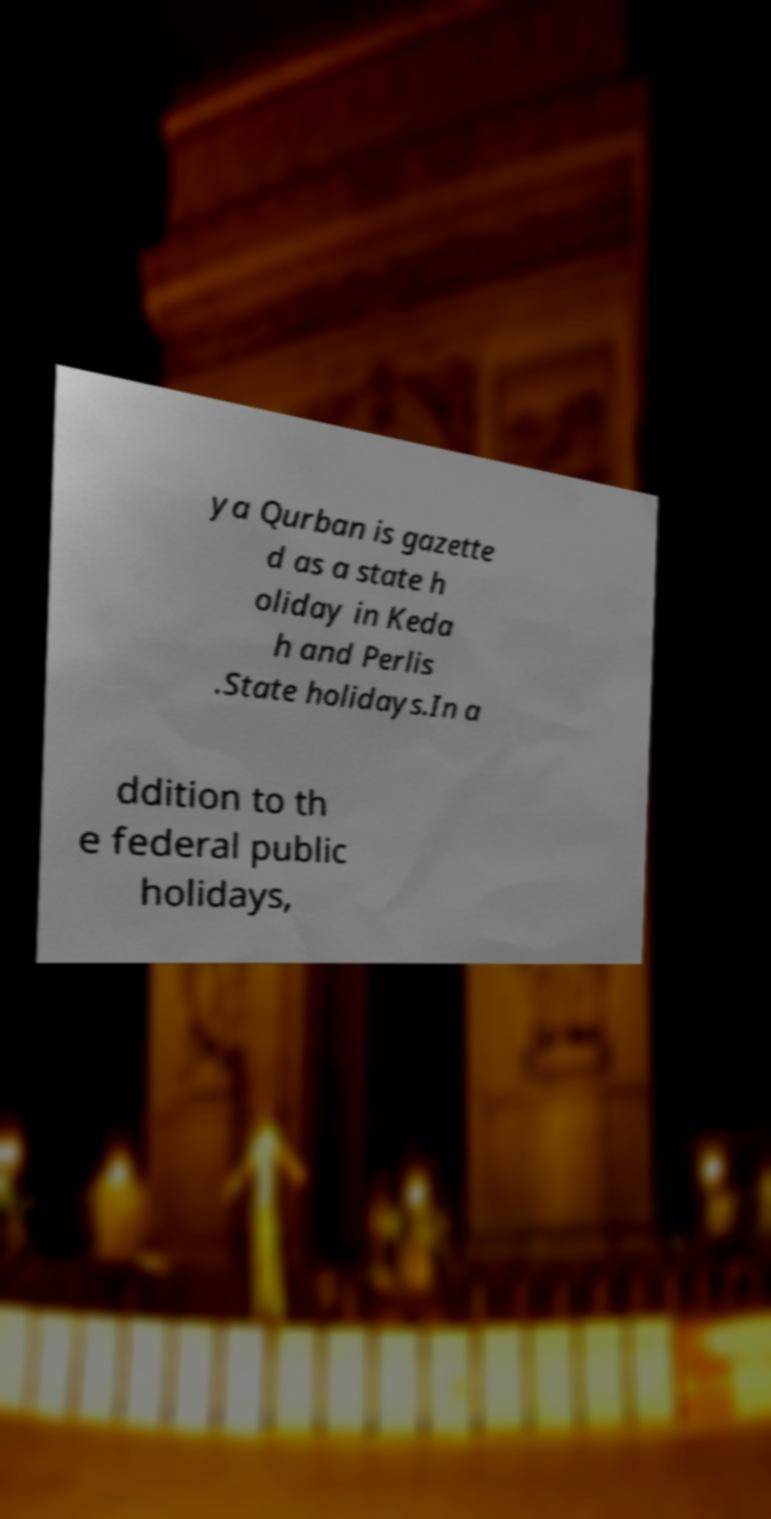Could you assist in decoding the text presented in this image and type it out clearly? ya Qurban is gazette d as a state h oliday in Keda h and Perlis .State holidays.In a ddition to th e federal public holidays, 